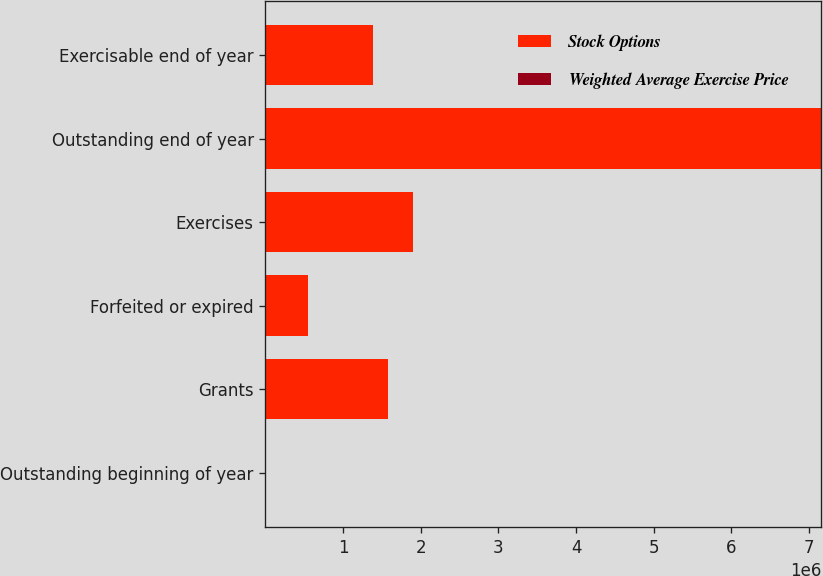<chart> <loc_0><loc_0><loc_500><loc_500><stacked_bar_chart><ecel><fcel>Outstanding beginning of year<fcel>Grants<fcel>Forfeited or expired<fcel>Exercises<fcel>Outstanding end of year<fcel>Exercisable end of year<nl><fcel>Stock Options<fcel>55.46<fcel>1.58112e+06<fcel>541853<fcel>1.90502e+06<fcel>7.15955e+06<fcel>1.39085e+06<nl><fcel>Weighted Average Exercise Price<fcel>28.26<fcel>55.46<fcel>34.02<fcel>20.01<fcel>35.92<fcel>22.36<nl></chart> 